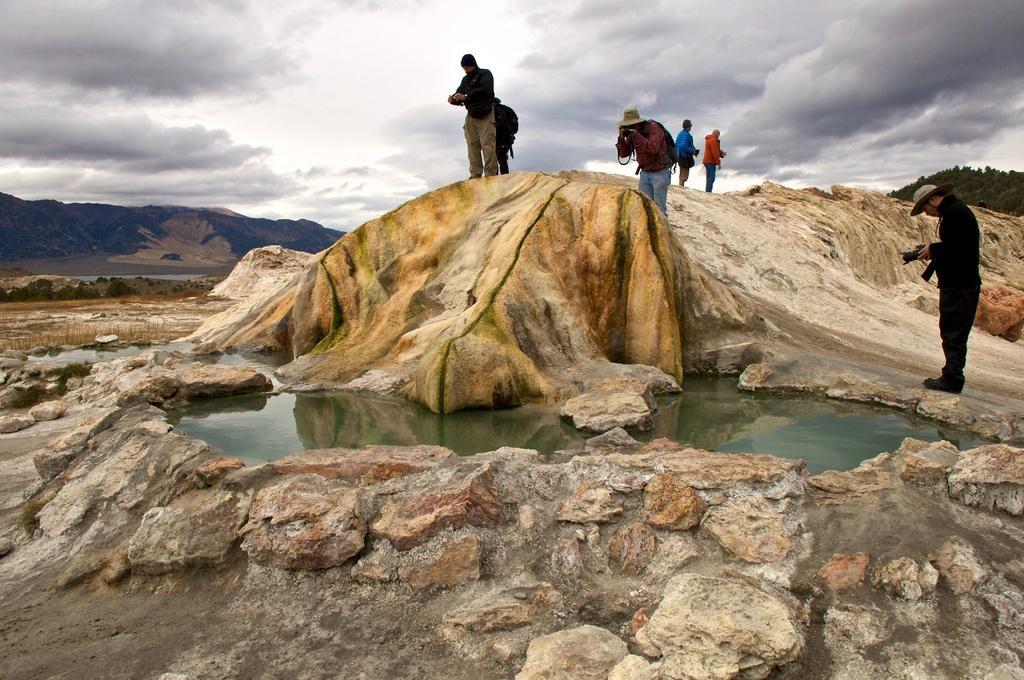Can you describe this image briefly? In this image, we can see people and some are wearing coats, hats and holding some objects and we can see rocks and hills and there is water. At the top, there are clouds in the sky. 